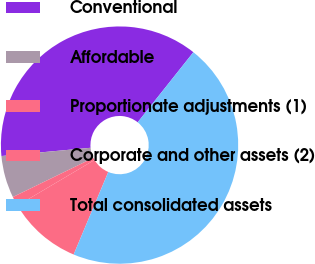<chart> <loc_0><loc_0><loc_500><loc_500><pie_chart><fcel>Conventional<fcel>Affordable<fcel>Proportionate adjustments (1)<fcel>Corporate and other assets (2)<fcel>Total consolidated assets<nl><fcel>37.16%<fcel>5.74%<fcel>1.3%<fcel>10.17%<fcel>45.64%<nl></chart> 